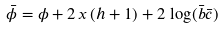Convert formula to latex. <formula><loc_0><loc_0><loc_500><loc_500>\bar { \phi } = \phi + 2 \, x \, ( h + 1 ) + 2 \, \log ( \bar { b } \bar { c } )</formula> 